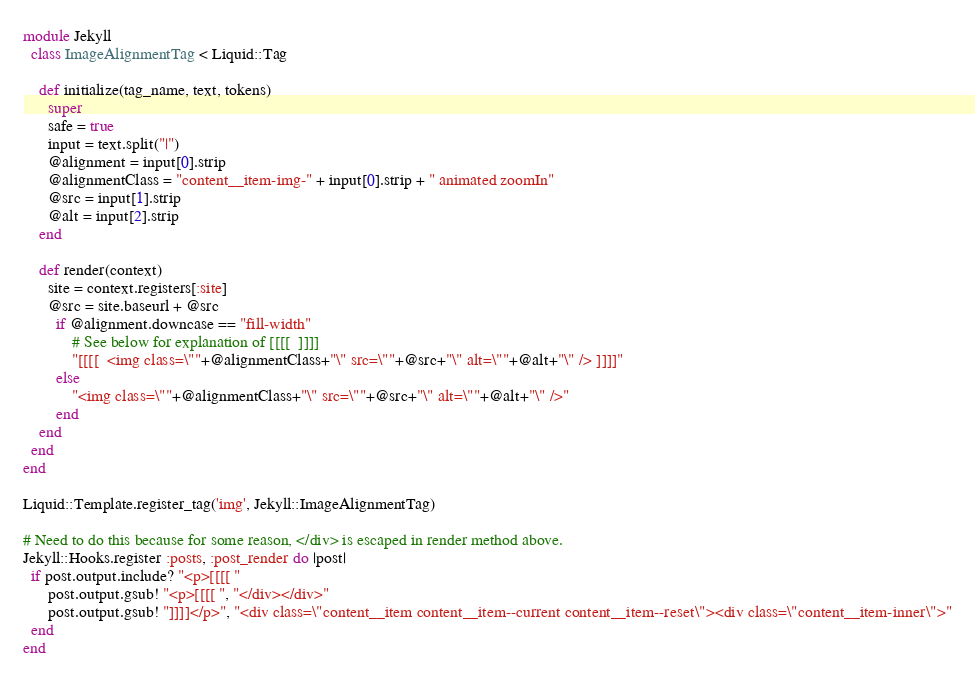<code> <loc_0><loc_0><loc_500><loc_500><_Ruby_>module Jekyll
  class ImageAlignmentTag < Liquid::Tag

    def initialize(tag_name, text, tokens)
      super
      safe = true
      input = text.split("|")
      @alignment = input[0].strip
      @alignmentClass = "content__item-img-" + input[0].strip + " animated zoomIn"
      @src = input[1].strip
      @alt = input[2].strip
    end

    def render(context)
      site = context.registers[:site]
      @src = site.baseurl + @src
        if @alignment.downcase == "fill-width"
            # See below for explanation of [[[[  ]]]]
            "[[[[  <img class=\""+@alignmentClass+"\" src=\""+@src+"\" alt=\""+@alt+"\" /> ]]]]"
        else
            "<img class=\""+@alignmentClass+"\" src=\""+@src+"\" alt=\""+@alt+"\" />"
        end
    end
  end
end

Liquid::Template.register_tag('img', Jekyll::ImageAlignmentTag)

# Need to do this because for some reason, </div> is escaped in render method above.
Jekyll::Hooks.register :posts, :post_render do |post|
  if post.output.include? "<p>[[[[ "
      post.output.gsub! "<p>[[[[ ", "</div></div>"
      post.output.gsub! "]]]]</p>", "<div class=\"content__item content__item--current content__item--reset\"><div class=\"content__item-inner\">"
  end
end
</code> 